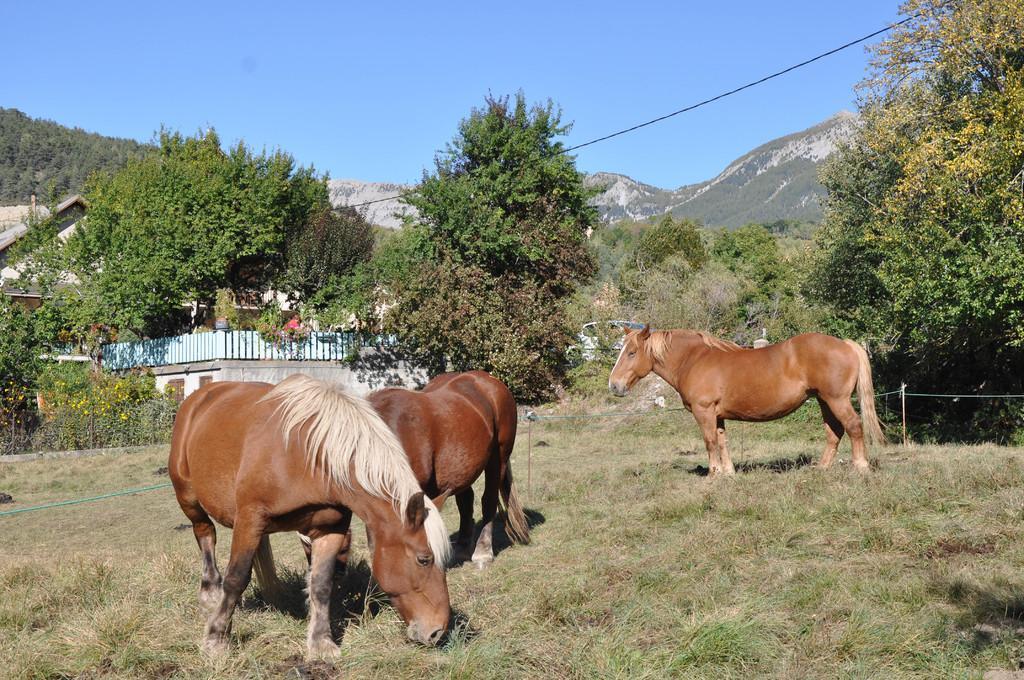Please provide a concise description of this image. In this picture we can see three horses on the ground, rope, trees, mountains, building, fences, sticks and in the background we can see the sky. 